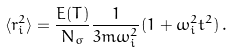<formula> <loc_0><loc_0><loc_500><loc_500>\langle r _ { i } ^ { 2 } \rangle = { \frac { E ( T ) } { N _ { \sigma } } } { \frac { 1 } { 3 m \omega _ { i } ^ { 2 } } } ( 1 + \omega _ { i } ^ { 2 } t ^ { 2 } ) \, .</formula> 